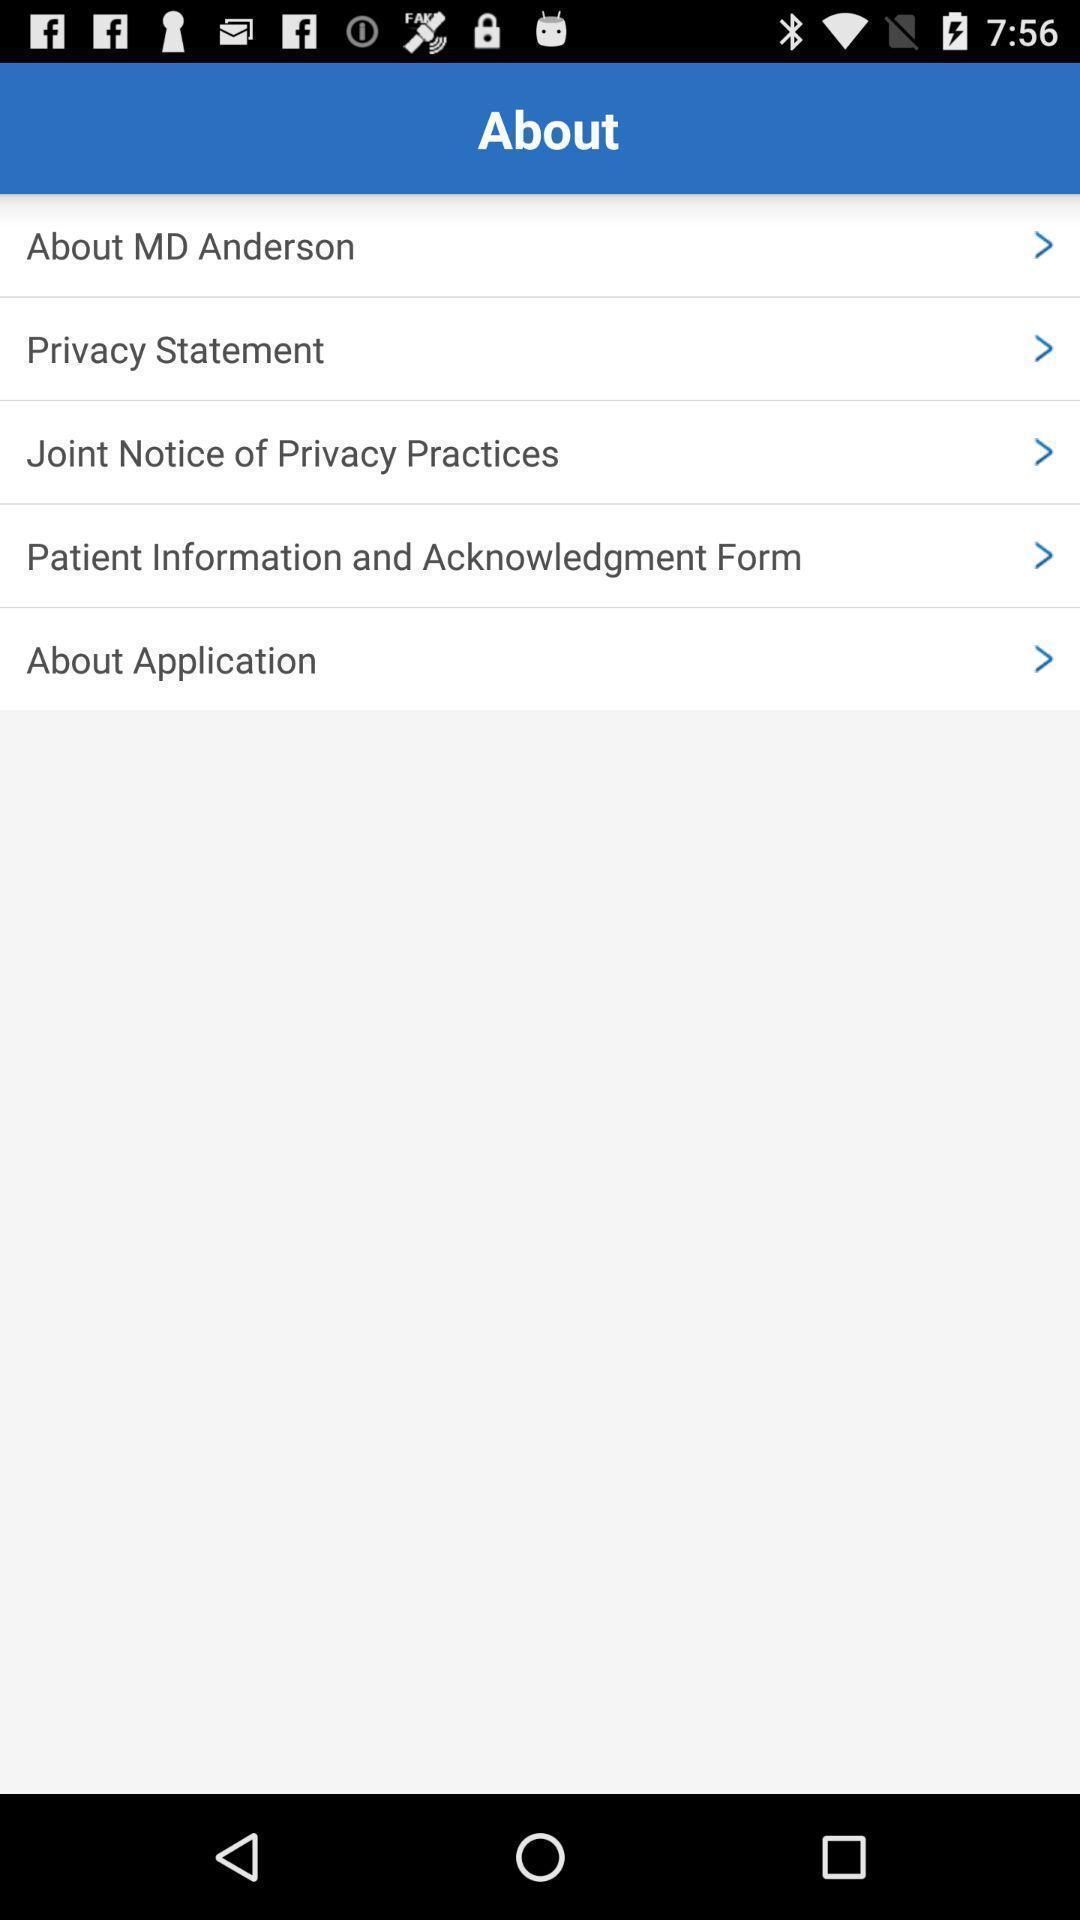Describe this image in words. Page displays about an application. 